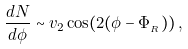<formula> <loc_0><loc_0><loc_500><loc_500>\frac { d N } { d \phi } \sim v _ { 2 } \cos ( 2 ( \phi - \Phi _ { _ { R } } ) ) \, ,</formula> 